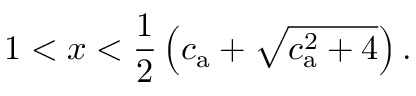Convert formula to latex. <formula><loc_0><loc_0><loc_500><loc_500>1 < x < \frac { 1 } { 2 } \left ( c _ { a } + \sqrt { c _ { a } ^ { 2 } + 4 } \right ) .</formula> 